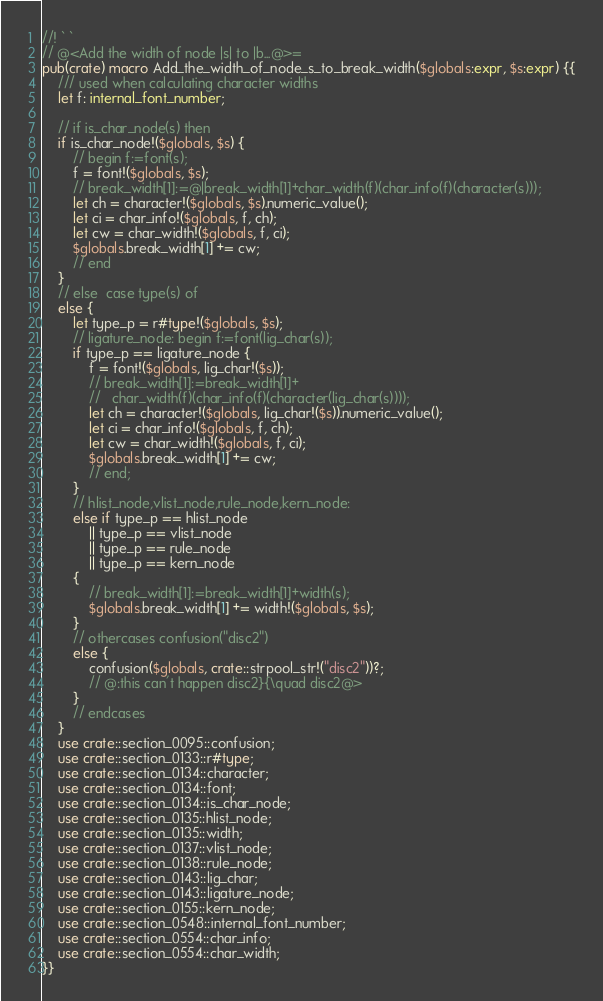<code> <loc_0><loc_0><loc_500><loc_500><_Rust_>//! ` `
// @<Add the width of node |s| to |b...@>=
pub(crate) macro Add_the_width_of_node_s_to_break_width($globals:expr, $s:expr) {{
    /// used when calculating character widths
    let f: internal_font_number;

    // if is_char_node(s) then
    if is_char_node!($globals, $s) {
        // begin f:=font(s);
        f = font!($globals, $s);
        // break_width[1]:=@|break_width[1]+char_width(f)(char_info(f)(character(s)));
        let ch = character!($globals, $s).numeric_value();
        let ci = char_info!($globals, f, ch);
        let cw = char_width!($globals, f, ci);
        $globals.break_width[1] += cw;
        // end
    }
    // else  case type(s) of
    else {
        let type_p = r#type!($globals, $s);
        // ligature_node: begin f:=font(lig_char(s));
        if type_p == ligature_node {
            f = font!($globals, lig_char!($s));
            // break_width[1]:=break_width[1]+
            //   char_width(f)(char_info(f)(character(lig_char(s))));
            let ch = character!($globals, lig_char!($s)).numeric_value();
            let ci = char_info!($globals, f, ch);
            let cw = char_width!($globals, f, ci);
            $globals.break_width[1] += cw;
            // end;
        }
        // hlist_node,vlist_node,rule_node,kern_node:
        else if type_p == hlist_node
            || type_p == vlist_node
            || type_p == rule_node
            || type_p == kern_node
        {
            // break_width[1]:=break_width[1]+width(s);
            $globals.break_width[1] += width!($globals, $s);
        }
        // othercases confusion("disc2")
        else {
            confusion($globals, crate::strpool_str!("disc2"))?;
            // @:this can't happen disc2}{\quad disc2@>
        }
        // endcases
    }
    use crate::section_0095::confusion;
    use crate::section_0133::r#type;
    use crate::section_0134::character;
    use crate::section_0134::font;
    use crate::section_0134::is_char_node;
    use crate::section_0135::hlist_node;
    use crate::section_0135::width;
    use crate::section_0137::vlist_node;
    use crate::section_0138::rule_node;
    use crate::section_0143::lig_char;
    use crate::section_0143::ligature_node;
    use crate::section_0155::kern_node;
    use crate::section_0548::internal_font_number;
    use crate::section_0554::char_info;
    use crate::section_0554::char_width;
}}
</code> 